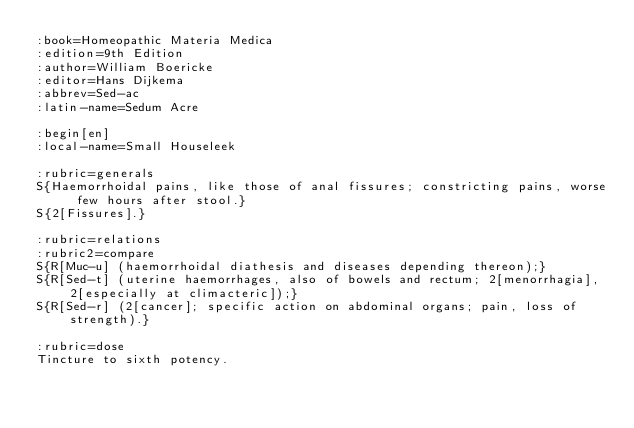<code> <loc_0><loc_0><loc_500><loc_500><_ObjectiveC_>:book=Homeopathic Materia Medica
:edition=9th Edition
:author=William Boericke
:editor=Hans Dijkema
:abbrev=Sed-ac
:latin-name=Sedum Acre

:begin[en]
:local-name=Small Houseleek

:rubric=generals
S{Haemorrhoidal pains, like those of anal fissures; constricting pains, worse few hours after stool.}
S{2[Fissures].}

:rubric=relations
:rubric2=compare
S{R[Muc-u] (haemorrhoidal diathesis and diseases depending thereon);}
S{R[Sed-t] (uterine haemorrhages, also of bowels and rectum; 2[menorrhagia], 2[especially at climacteric]);} 
S{R[Sed-r] (2[cancer]; specific action on abdominal organs; pain, loss of strength).}

:rubric=dose
Tincture to sixth potency.</code> 